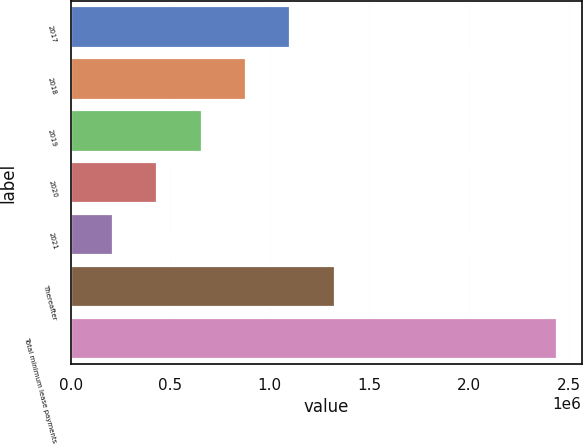Convert chart to OTSL. <chart><loc_0><loc_0><loc_500><loc_500><bar_chart><fcel>2017<fcel>2018<fcel>2019<fcel>2020<fcel>2021<fcel>Thereafter<fcel>Total minimum lease payments<nl><fcel>1.10334e+06<fcel>880117<fcel>656897<fcel>433678<fcel>210458<fcel>1.32656e+06<fcel>2.44266e+06<nl></chart> 